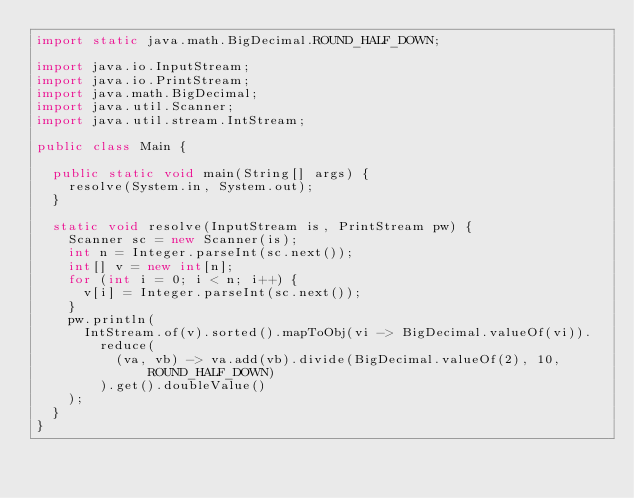Convert code to text. <code><loc_0><loc_0><loc_500><loc_500><_Java_>import static java.math.BigDecimal.ROUND_HALF_DOWN;

import java.io.InputStream;
import java.io.PrintStream;
import java.math.BigDecimal;
import java.util.Scanner;
import java.util.stream.IntStream;

public class Main {

  public static void main(String[] args) {
    resolve(System.in, System.out);
  }

  static void resolve(InputStream is, PrintStream pw) {
    Scanner sc = new Scanner(is);
    int n = Integer.parseInt(sc.next());
    int[] v = new int[n];
    for (int i = 0; i < n; i++) {
      v[i] = Integer.parseInt(sc.next());
    }
    pw.println(
      IntStream.of(v).sorted().mapToObj(vi -> BigDecimal.valueOf(vi)).
        reduce(
          (va, vb) -> va.add(vb).divide(BigDecimal.valueOf(2), 10, ROUND_HALF_DOWN)
        ).get().doubleValue()
    );
  }
}
</code> 